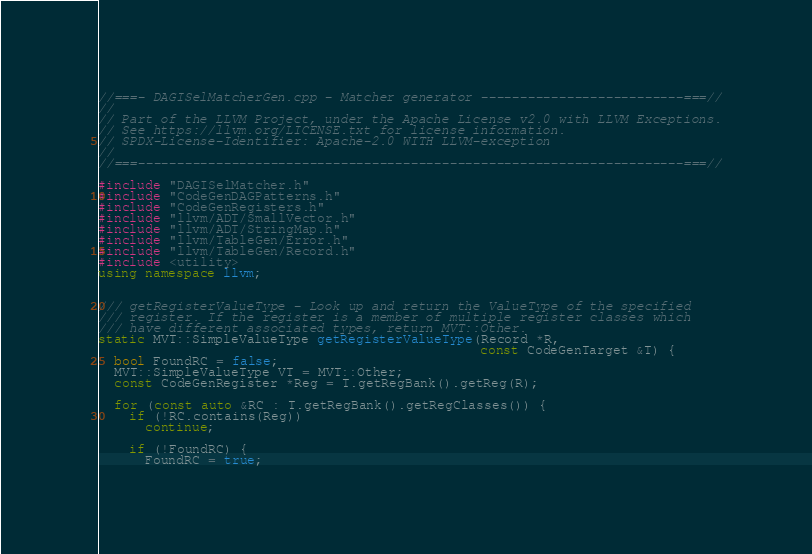Convert code to text. <code><loc_0><loc_0><loc_500><loc_500><_C++_>//===- DAGISelMatcherGen.cpp - Matcher generator --------------------------===//
//
// Part of the LLVM Project, under the Apache License v2.0 with LLVM Exceptions.
// See https://llvm.org/LICENSE.txt for license information.
// SPDX-License-Identifier: Apache-2.0 WITH LLVM-exception
//
//===----------------------------------------------------------------------===//

#include "DAGISelMatcher.h"
#include "CodeGenDAGPatterns.h"
#include "CodeGenRegisters.h"
#include "llvm/ADT/SmallVector.h"
#include "llvm/ADT/StringMap.h"
#include "llvm/TableGen/Error.h"
#include "llvm/TableGen/Record.h"
#include <utility>
using namespace llvm;


/// getRegisterValueType - Look up and return the ValueType of the specified
/// register. If the register is a member of multiple register classes which
/// have different associated types, return MVT::Other.
static MVT::SimpleValueType getRegisterValueType(Record *R,
                                                 const CodeGenTarget &T) {
  bool FoundRC = false;
  MVT::SimpleValueType VT = MVT::Other;
  const CodeGenRegister *Reg = T.getRegBank().getReg(R);

  for (const auto &RC : T.getRegBank().getRegClasses()) {
    if (!RC.contains(Reg))
      continue;

    if (!FoundRC) {
      FoundRC = true;</code> 